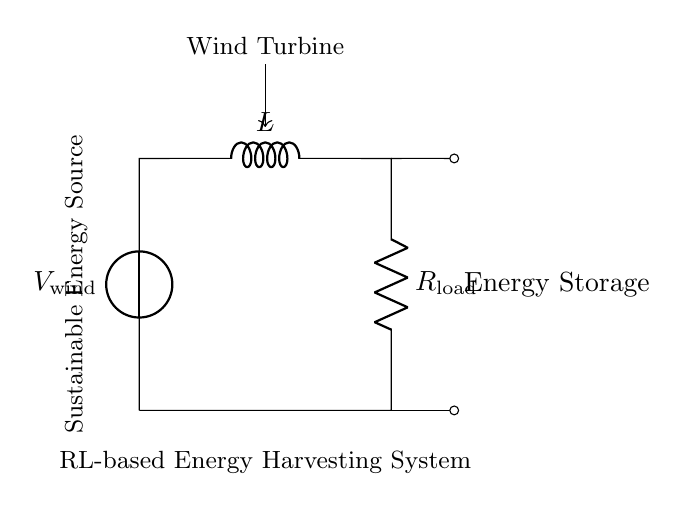What is the source voltage in this circuit? The circuit has a voltage source labeled as V wind, indicating the source voltage is related to wind energy conversion.
Answer: V wind What components are part of this RL-based energy harvesting system? The components include a voltage source, an inductor labeled L, and a resistor labeled R load, connected in series.
Answer: Voltage source, inductor, resistor What does the inductor do in this energy harvesting system? The inductor stores energy temporarily from the wind-generated voltage and helps smoothe out fluctuations in current flow.
Answer: Stores energy Why is a resistor needed in this circuit? The resistor, R load, is used to convert the electrical energy generated into useful work, typically as load resistance for energy consumption, like charging a battery.
Answer: Converts energy to work How does the energy flow through this system? Energy flows from the wind turbine, through the voltage source, into the inductor, and then through the resistor, where it is utilized as output.
Answer: From turbine to load What is the role of energy storage in this circuit? The energy storage serves to hold onto the electrical energy generated by the inductor, allowing for later use when the wind is not sufficient for direct generation.
Answer: Helps retain energy 